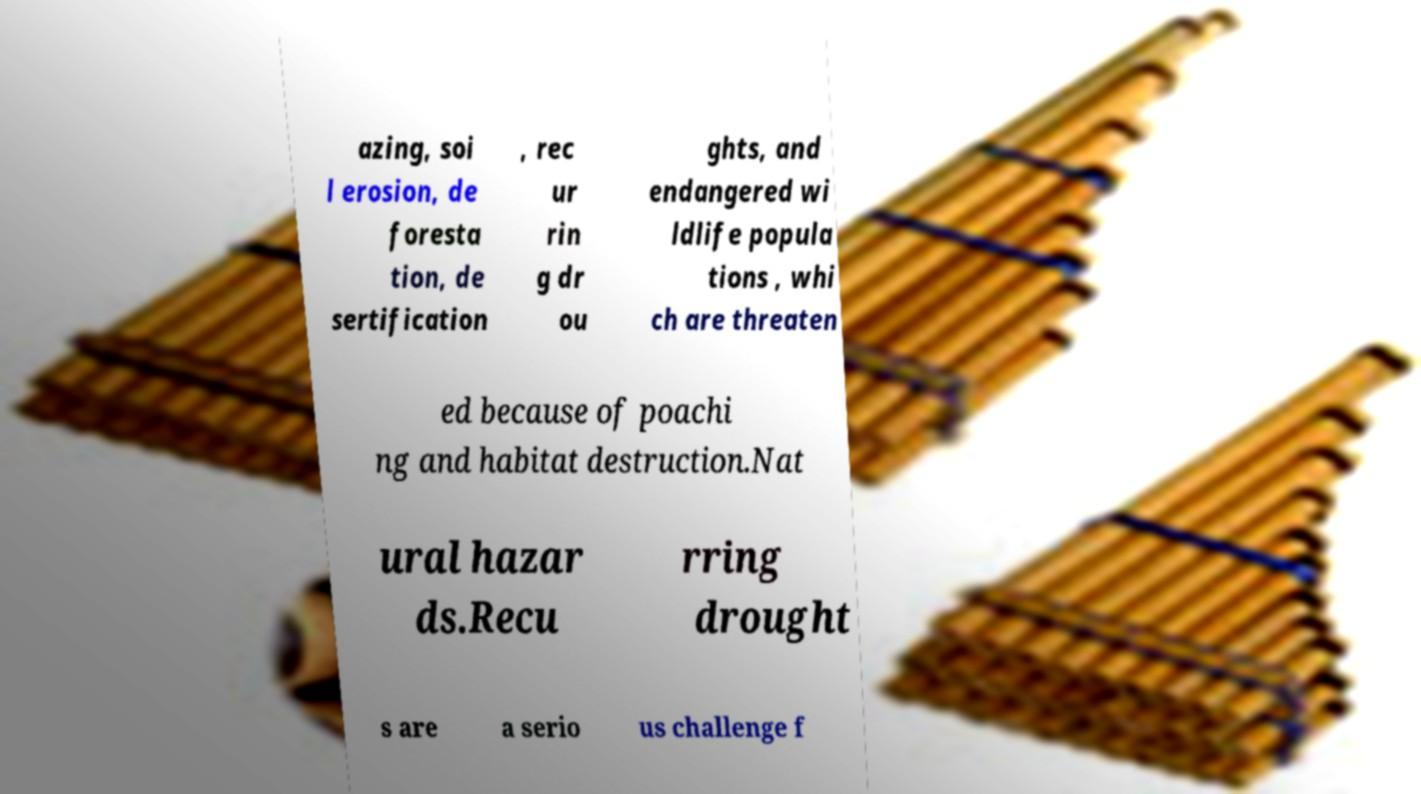I need the written content from this picture converted into text. Can you do that? azing, soi l erosion, de foresta tion, de sertification , rec ur rin g dr ou ghts, and endangered wi ldlife popula tions , whi ch are threaten ed because of poachi ng and habitat destruction.Nat ural hazar ds.Recu rring drought s are a serio us challenge f 